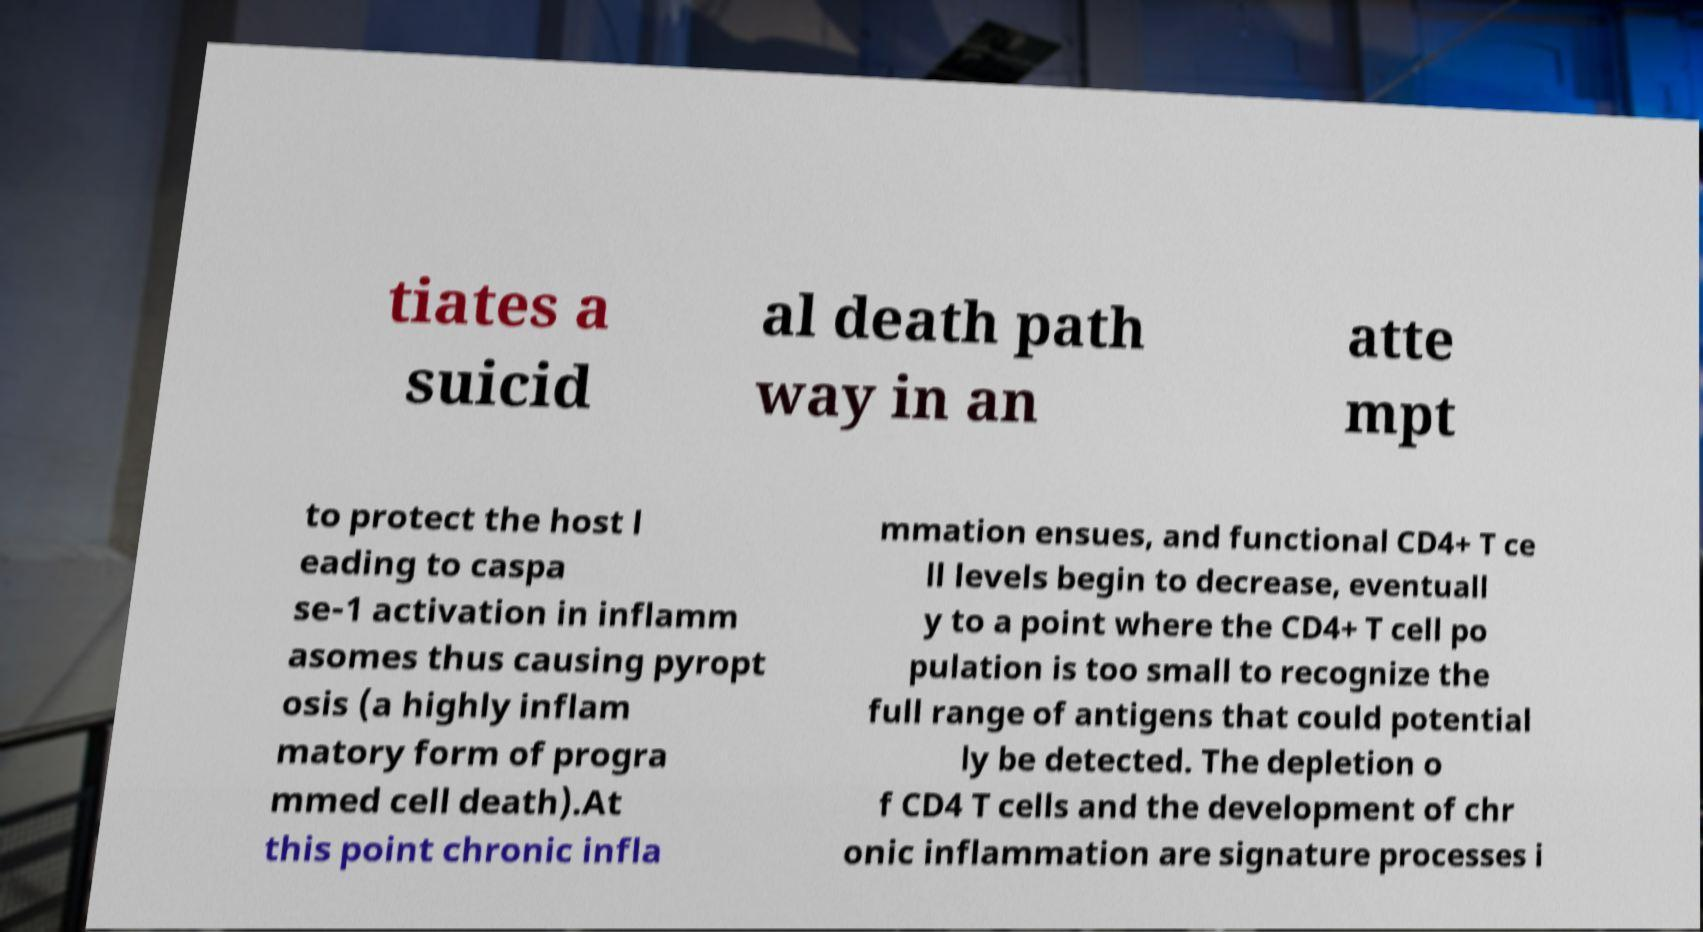I need the written content from this picture converted into text. Can you do that? tiates a suicid al death path way in an atte mpt to protect the host l eading to caspa se-1 activation in inflamm asomes thus causing pyropt osis (a highly inflam matory form of progra mmed cell death).At this point chronic infla mmation ensues, and functional CD4+ T ce ll levels begin to decrease, eventuall y to a point where the CD4+ T cell po pulation is too small to recognize the full range of antigens that could potential ly be detected. The depletion o f CD4 T cells and the development of chr onic inflammation are signature processes i 